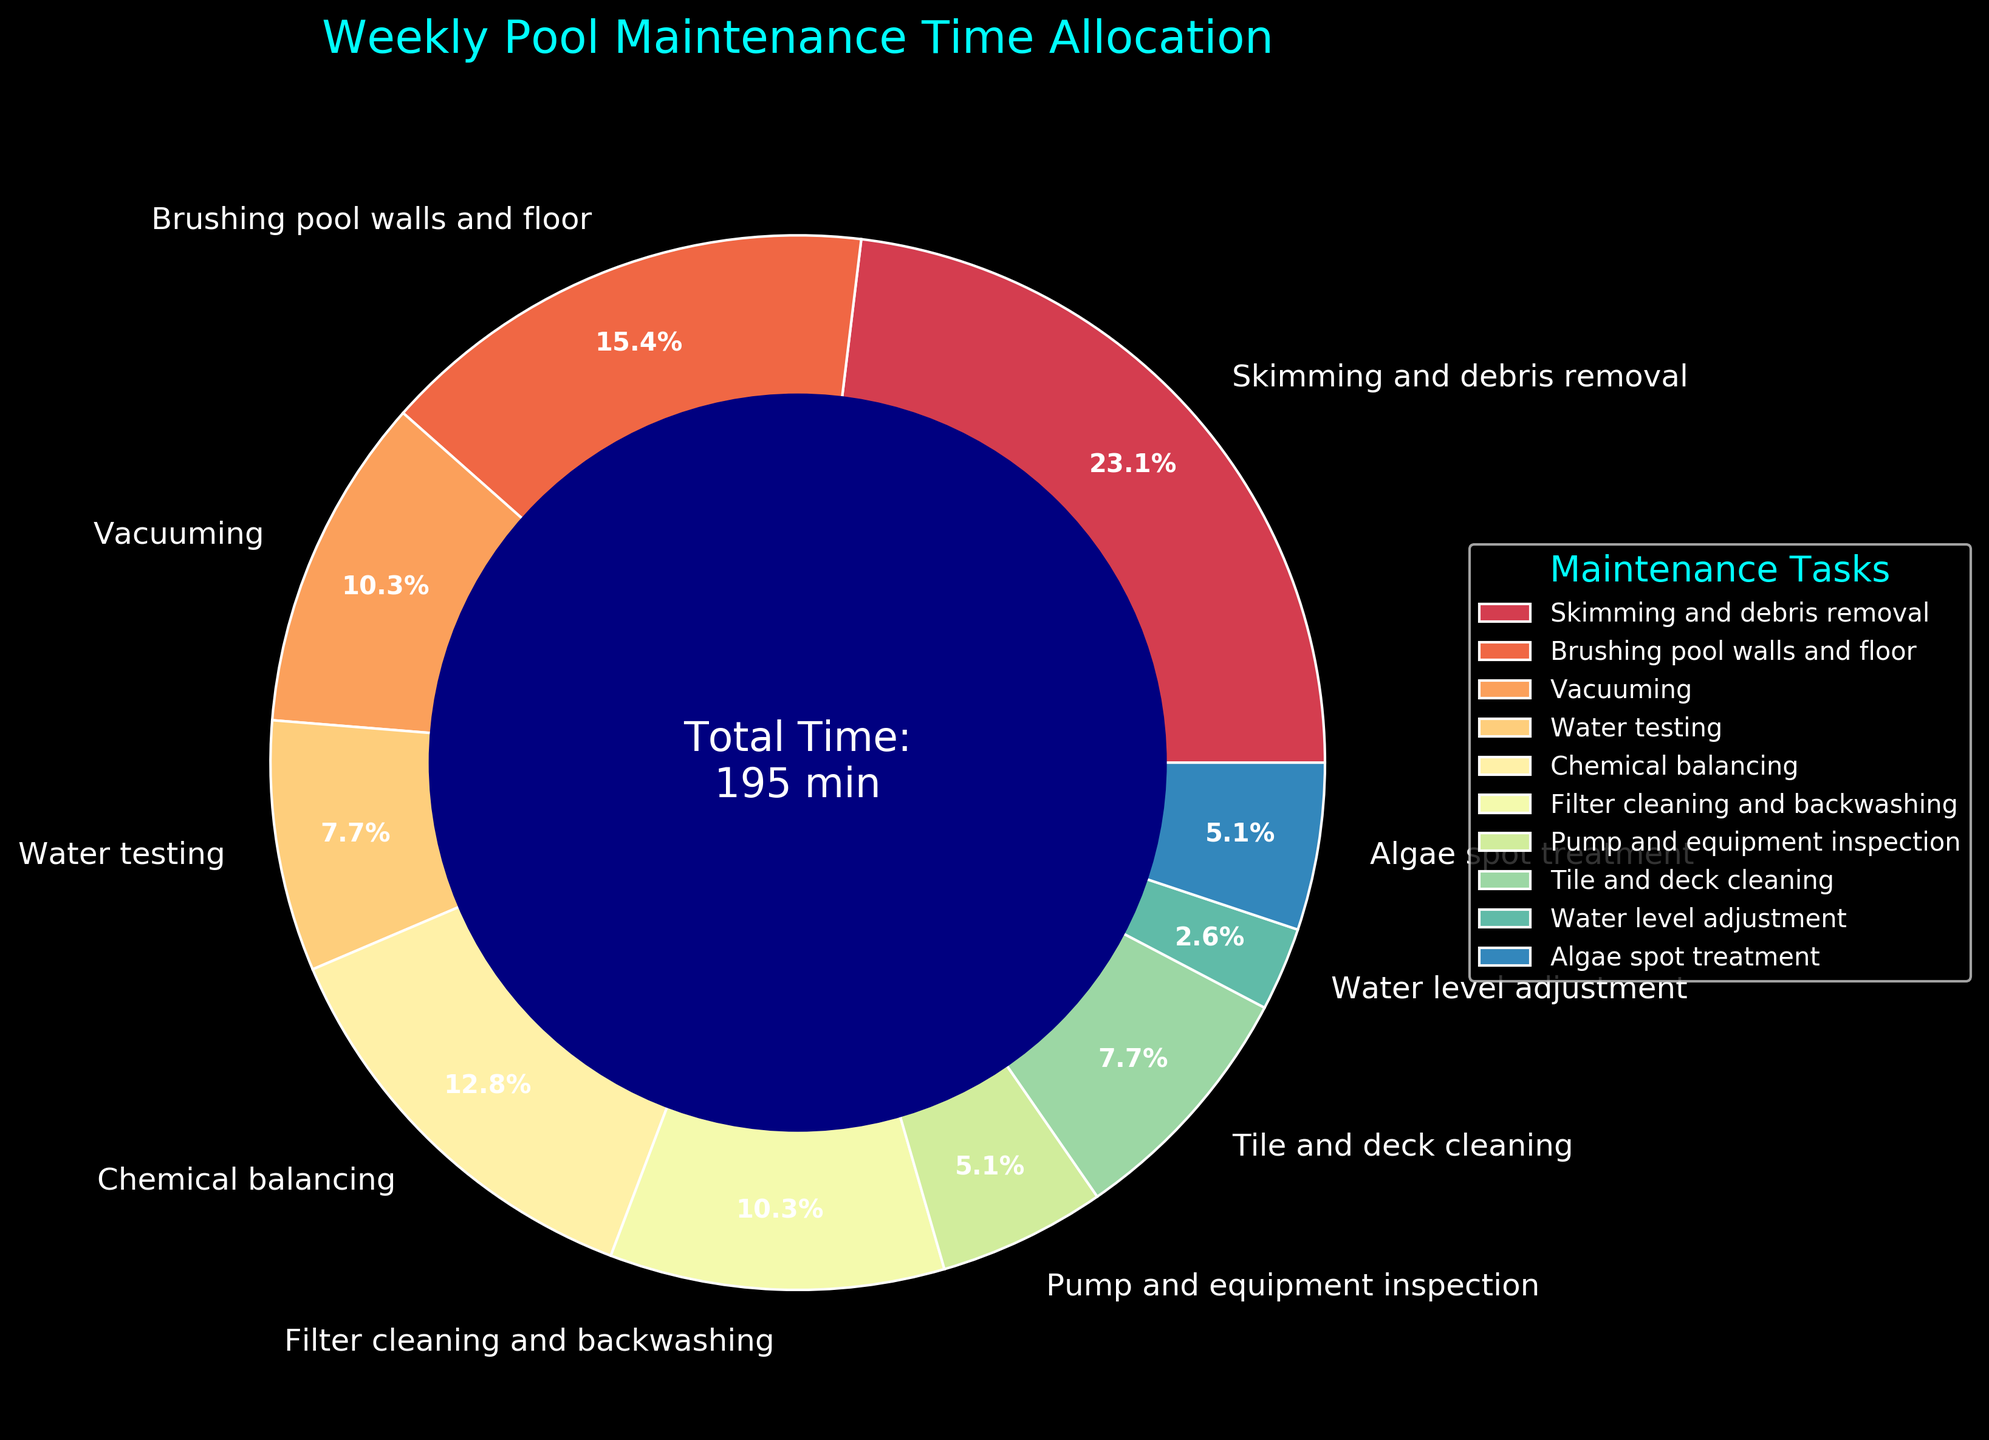Which task takes up the largest portion of the weekly pool maintenance time? From the chart, the task with the largest segment is "Skimming and debris removal", which occupies the largest portion of the pie.
Answer: Skimming and debris removal Compare the time spent on "Brushing pool walls and floor" and "Chemical balancing". Which task takes more time? By comparing the sizes of the segments for "Brushing pool walls and floor" and "Chemical balancing", it is clear that "Brushing pool walls and floor" takes more time.
Answer: Brushing pool walls and floor How much total time is spent on "Pump and equipment inspection" and "Algae spot treatment" combined? The time for "Pump and equipment inspection" is 10 minutes and for "Algae spot treatment" is 10 minutes. Adding these two gives 10 + 10 = 20 minutes.
Answer: 20 minutes Identify the task with the second smallest time allocation in the weekly maintenance schedule. Looking at the pie chart, the second smallest segment corresponds to "Water level adjustment" after "Pump and equipment inspection".
Answer: Water level adjustment What is the percentage of time dedicated to "Vacuuming" compared to the total time spent on weekly pool maintenance? The pie chart shows that the "Vacuuming" segment has a percentage of 20 / 195 * 100 ≈ 10.3%.
Answer: Approximately 10.3% Between "Tile and deck cleaning" and "Filter cleaning and backwashing", which task requires more time and by how much? The segment for "Tile and deck cleaning" represents 15 minutes while "Filter cleaning and backwashing" takes 20 minutes. The difference is 20 - 15 = 5 minutes.
Answer: Filter cleaning and backwashing by 5 minutes What is the overall time spent on skimming, brushing, and vacuuming combined? The times are 45 minutes for skimming, 30 minutes for brushing, and 20 minutes for vacuuming. Adding these gives 45 + 30 + 20 = 95 minutes.
Answer: 95 minutes Determine the task with the highest proportion relative to "Water testing". "Skimming and debris removal" has the highest proportion compared to "Water testing" when visually assessed from the pie chart.
Answer: Skimming and debris removal 